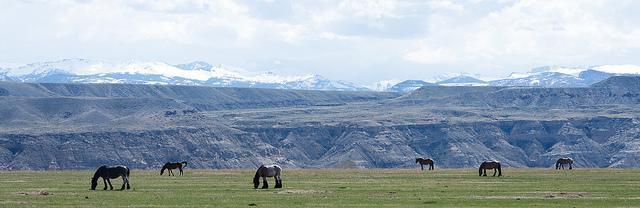How many horses are in the field?
Give a very brief answer. 6. How many people are holding drums on the right side of a raised hand?
Give a very brief answer. 0. 